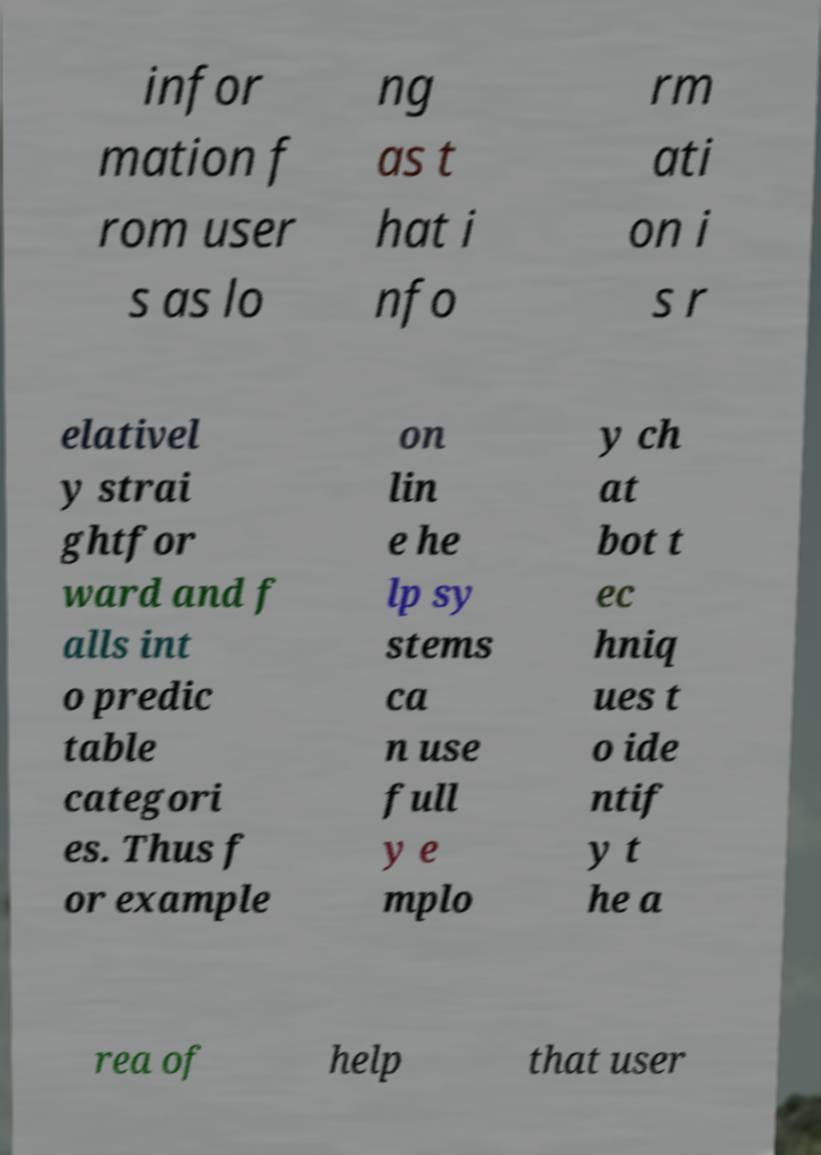Please identify and transcribe the text found in this image. infor mation f rom user s as lo ng as t hat i nfo rm ati on i s r elativel y strai ghtfor ward and f alls int o predic table categori es. Thus f or example on lin e he lp sy stems ca n use full y e mplo y ch at bot t ec hniq ues t o ide ntif y t he a rea of help that user 